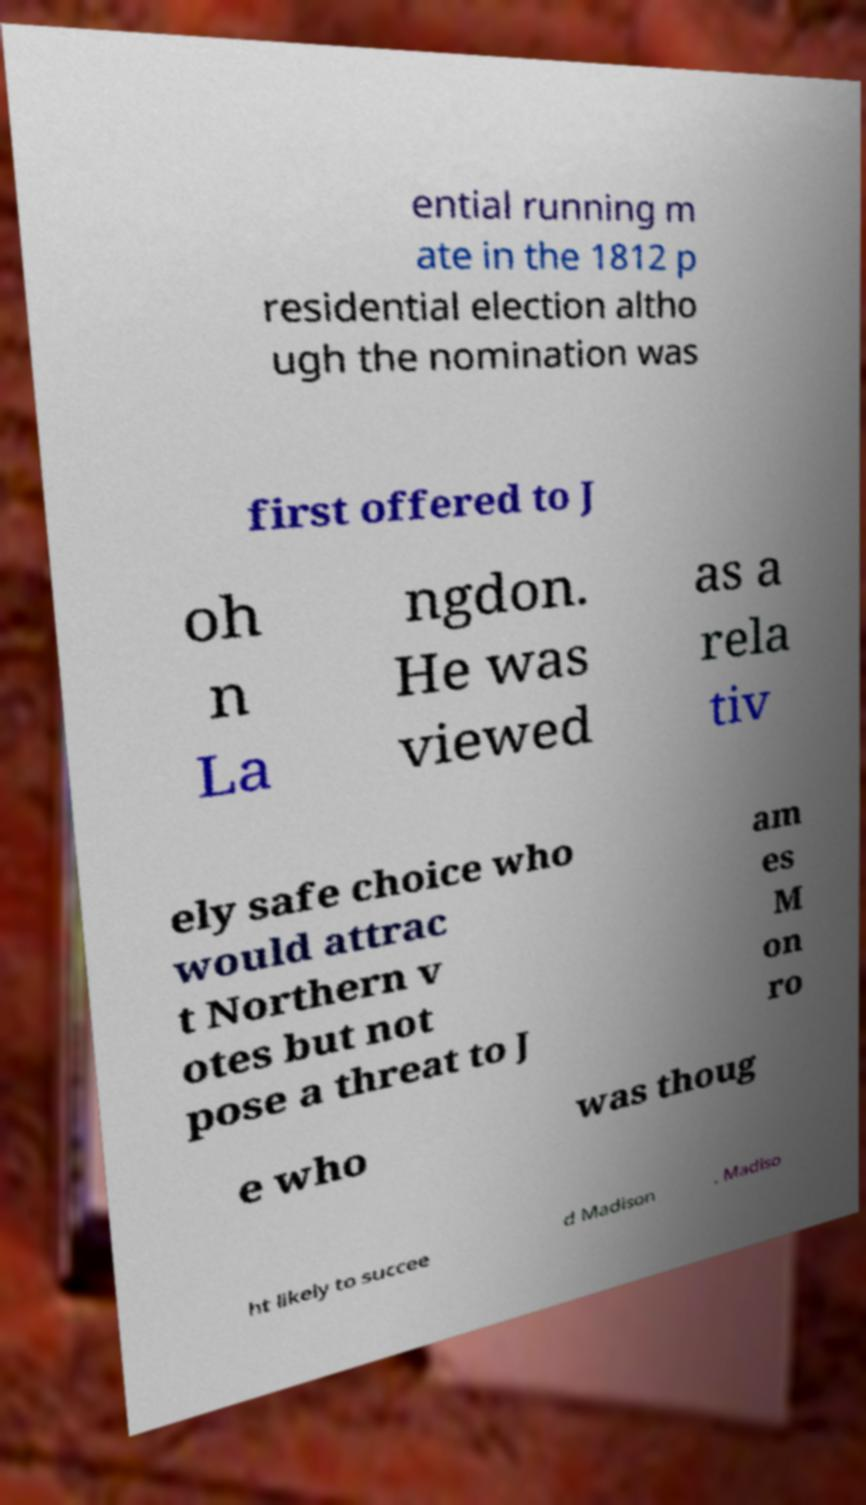Could you extract and type out the text from this image? ential running m ate in the 1812 p residential election altho ugh the nomination was first offered to J oh n La ngdon. He was viewed as a rela tiv ely safe choice who would attrac t Northern v otes but not pose a threat to J am es M on ro e who was thoug ht likely to succee d Madison . Madiso 